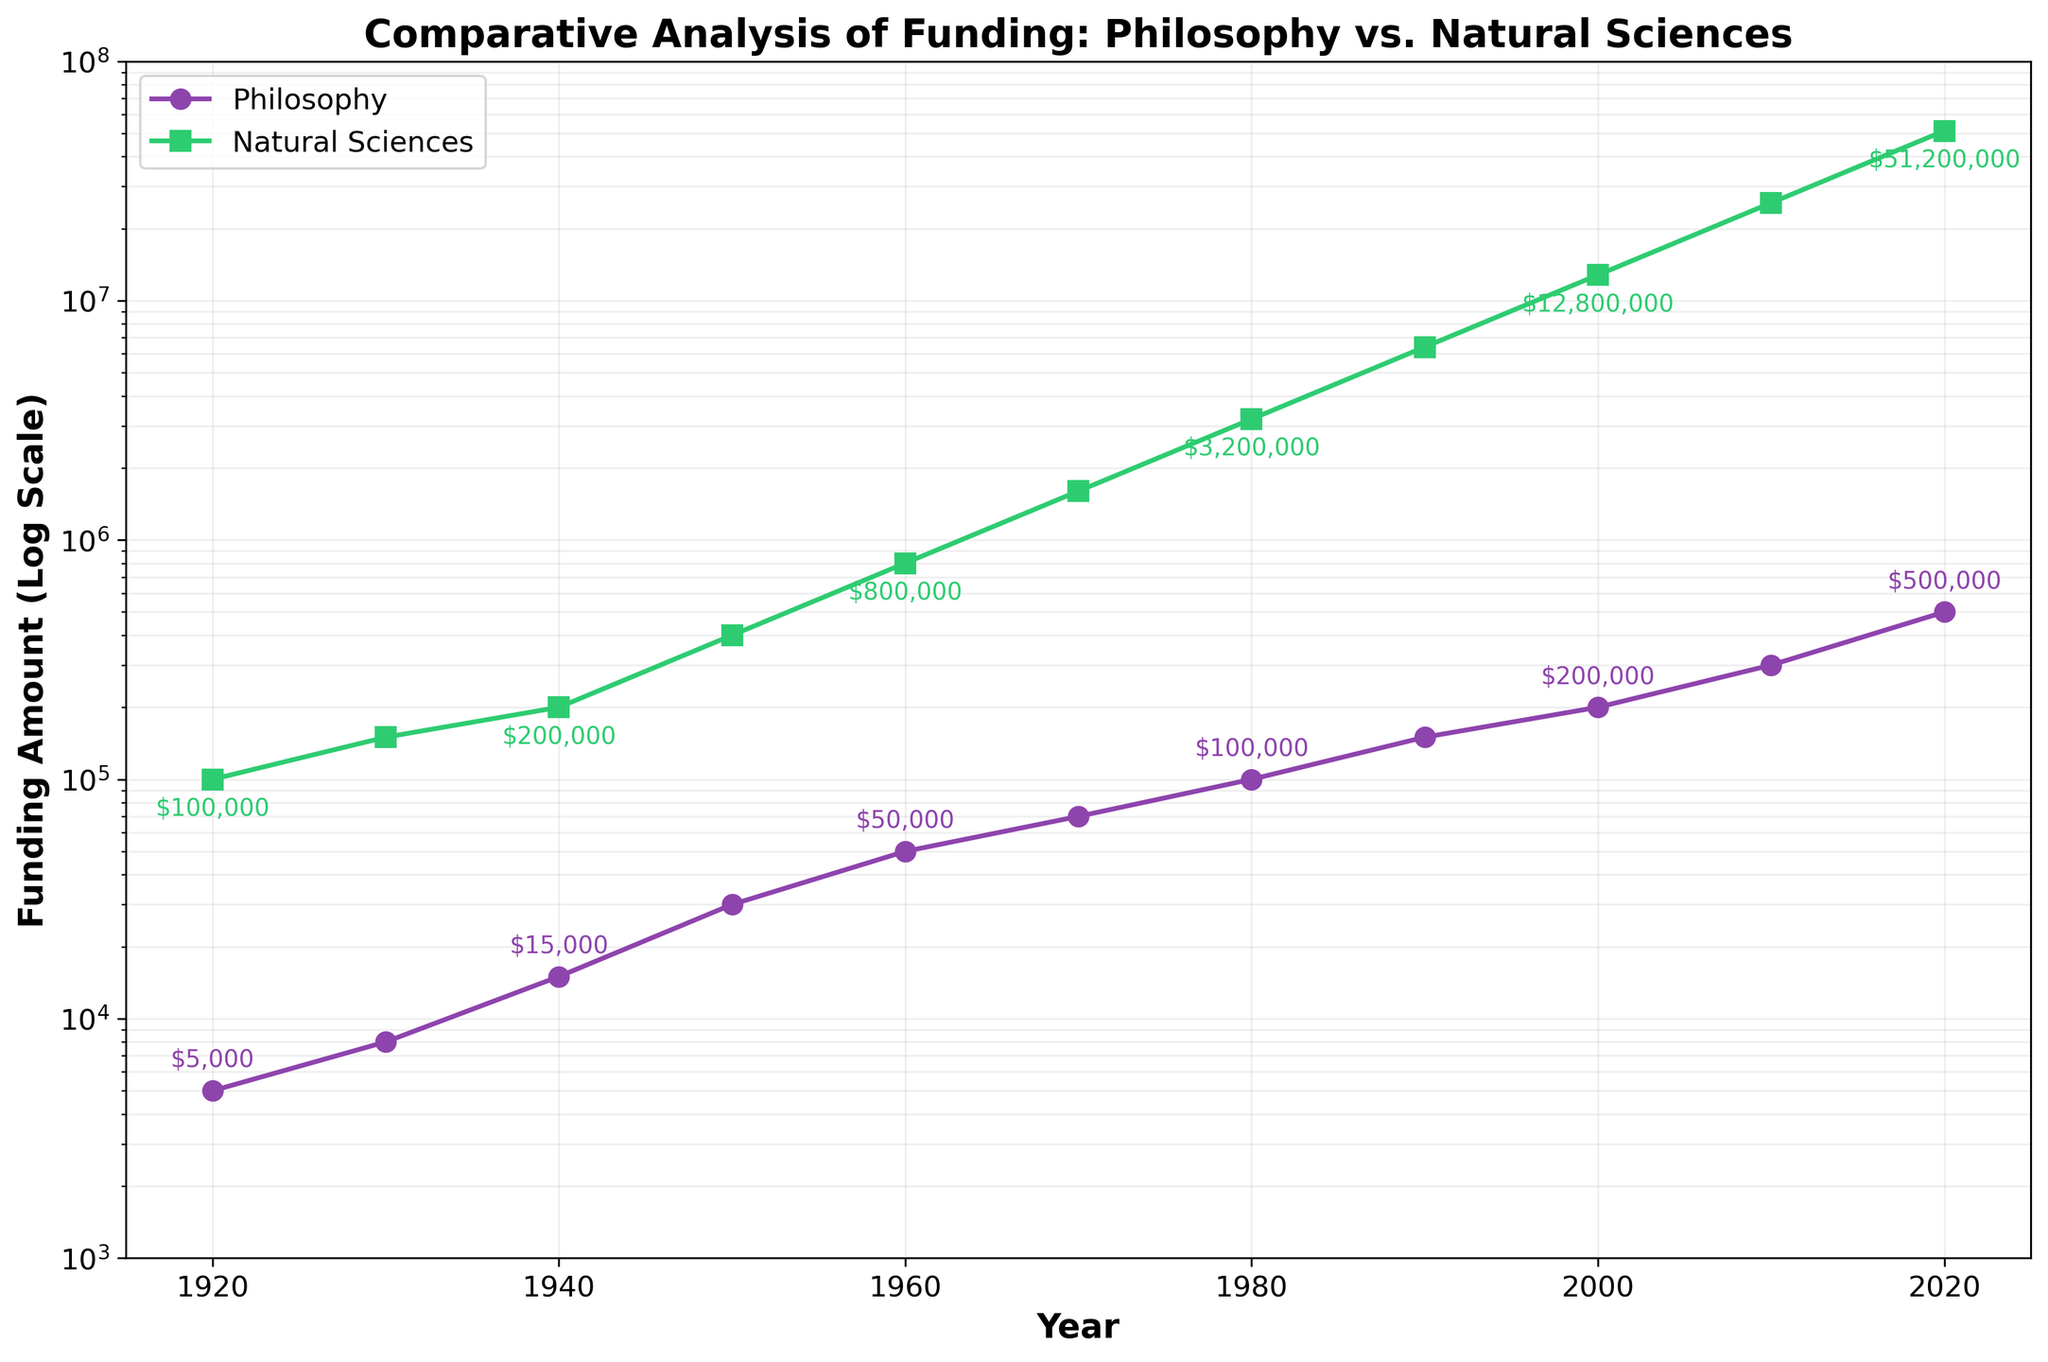How many years are represented in the figure? The figure shows data points starting from the year 1920 to the year 2020. To determine how many years are represented, count the data points, one for each decade.
Answer: 11 What is the title of the figure? To find the title, look just above the plot. It is usually displayed prominently to describe the main subject of the figure.
Answer: Comparative Analysis of Funding: Philosophy vs. Natural Sciences In which year did both Philosophy and Natural Sciences funding amounts appear to double from the previous decade? To answer this, look for points where annotations show double the amount of funding from the previous decade. For instance, in 1950, Philosophy funding is $30,000, doubled from $15,000 in 1940. Similarly, Natural Sciences funding is $400,000, doubled from $200,000 in 1940.
Answer: 1950 Which field received more funding in the year 1970? Compare the funding amounts for Philosophy and Natural Sciences alongside the same year point in the plot. For 1970, Philosophy received $70,000 and Natural Sciences received $1,600,000.
Answer: Natural Sciences By how much did the funding for Natural Sciences increase between 1920 and 2020? To find the increase, subtract the 1920 funding amount for Natural Sciences from the 2020 funding amount. From the plot, 2020 funding is $51,200,000, and 1920 funding is $100,000. So, $51,200,000 - $100,000.
Answer: $51,100,000 Which decade saw the highest percentage increase in Philosophy funding? Calculate the percentage increase by comparing each decade's funding amount. The percentage increase is the difference between two consecutive funding amounts divided by the earlier amount, multiplied by 100%. Check the highest value. For example, between 1930 ($8,000) and 1940 ($15,000): ((15,000 - 8,000) / 8,000) * 100% = 87.5%. Following this process, the highest increase is found between 1940 and 1950: ((30,000 - 15,000) / 15,000) * 100% = 100%.
Answer: 1940-1950 On a logarithmic scale, which funding shows relatively steadier growth - Philosophy or Natural Sciences? A relatively steadier growth on a logarithmic scale would appear as a more linear progression. By comparing the two curves, the Philosophy funding line looks more linear and consistent over the years than the Natural Sciences curve, which exhibits sharper changes.
Answer: Philosophy What was the ratio of Natural Sciences funding to Philosophy funding in the year 2000? Divide the Natural Sciences funding amount by Philosophy funding amount for that year. For 2000, Natural Sciences received $12,800,000, and Philosophy received $200,000. So, $12,800,000 / $200,000.
Answer: 64:1 Which annotation colors correspond to Philosophy and Natural Sciences, respectively? Observe the colors used for the data points and annotations. Philosophy funding points and annotations are shown in purple, while Natural Sciences are shown in green.
Answer: Purple and Green 